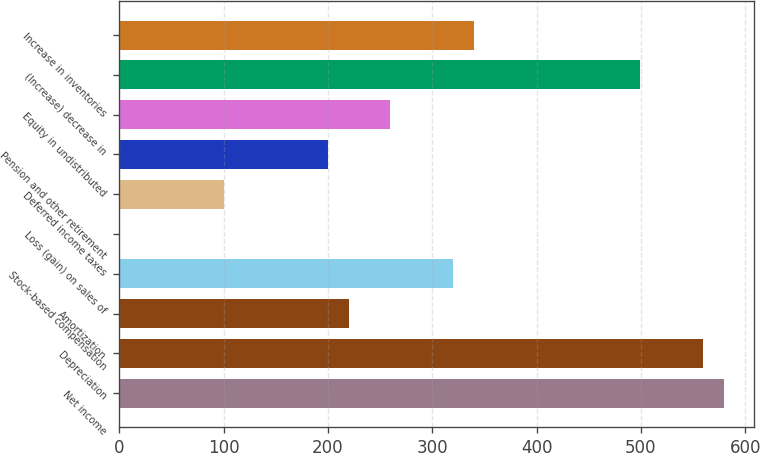Convert chart. <chart><loc_0><loc_0><loc_500><loc_500><bar_chart><fcel>Net income<fcel>Depreciation<fcel>Amortization<fcel>Stock-based compensation<fcel>Loss (gain) on sales of<fcel>Deferred income taxes<fcel>Pension and other retirement<fcel>Equity in undistributed<fcel>(Increase) decrease in<fcel>Increase in inventories<nl><fcel>579.33<fcel>559.36<fcel>219.87<fcel>319.72<fcel>0.2<fcel>100.05<fcel>199.9<fcel>259.81<fcel>499.45<fcel>339.69<nl></chart> 